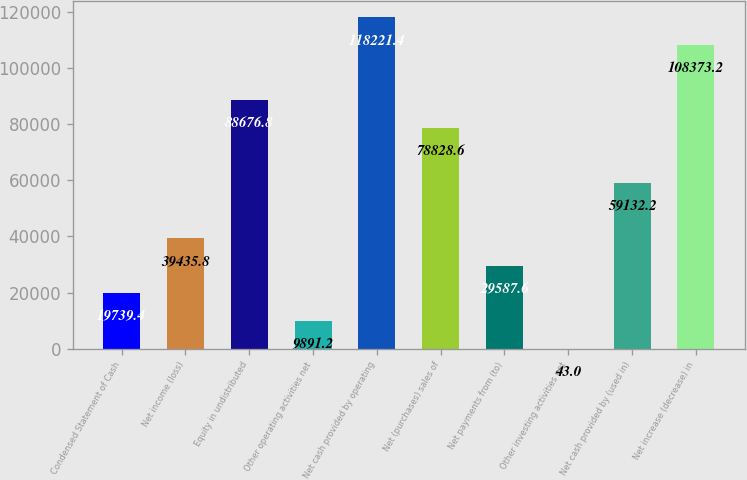Convert chart to OTSL. <chart><loc_0><loc_0><loc_500><loc_500><bar_chart><fcel>Condensed Statement of Cash<fcel>Net income (loss)<fcel>Equity in undistributed<fcel>Other operating activities net<fcel>Net cash provided by operating<fcel>Net (purchases) sales of<fcel>Net payments from (to)<fcel>Other investing activities net<fcel>Net cash provided by (used in)<fcel>Net increase (decrease) in<nl><fcel>19739.4<fcel>39435.8<fcel>88676.8<fcel>9891.2<fcel>118221<fcel>78828.6<fcel>29587.6<fcel>43<fcel>59132.2<fcel>108373<nl></chart> 